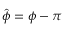<formula> <loc_0><loc_0><loc_500><loc_500>\hat { \phi } = \phi - \pi</formula> 